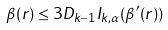<formula> <loc_0><loc_0><loc_500><loc_500>\beta ( r ) \leq 3 D _ { k - 1 } I _ { k , \alpha } ( \beta ^ { \prime } ( r ) )</formula> 